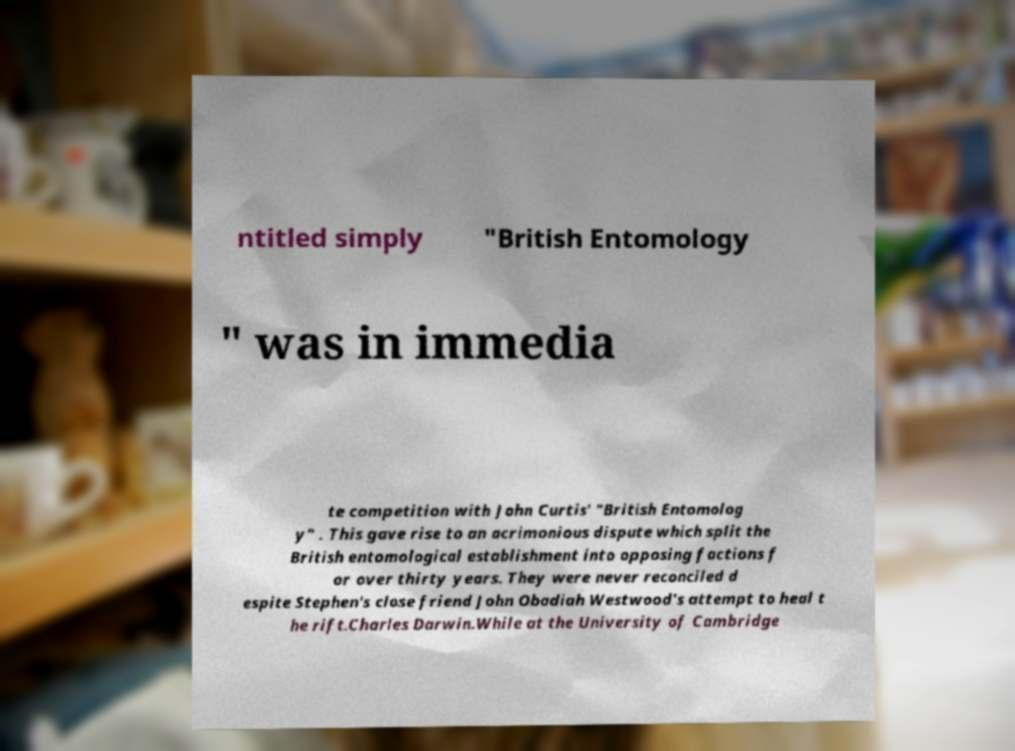Can you read and provide the text displayed in the image?This photo seems to have some interesting text. Can you extract and type it out for me? ntitled simply "British Entomology " was in immedia te competition with John Curtis' "British Entomolog y" . This gave rise to an acrimonious dispute which split the British entomological establishment into opposing factions f or over thirty years. They were never reconciled d espite Stephen's close friend John Obadiah Westwood's attempt to heal t he rift.Charles Darwin.While at the University of Cambridge 